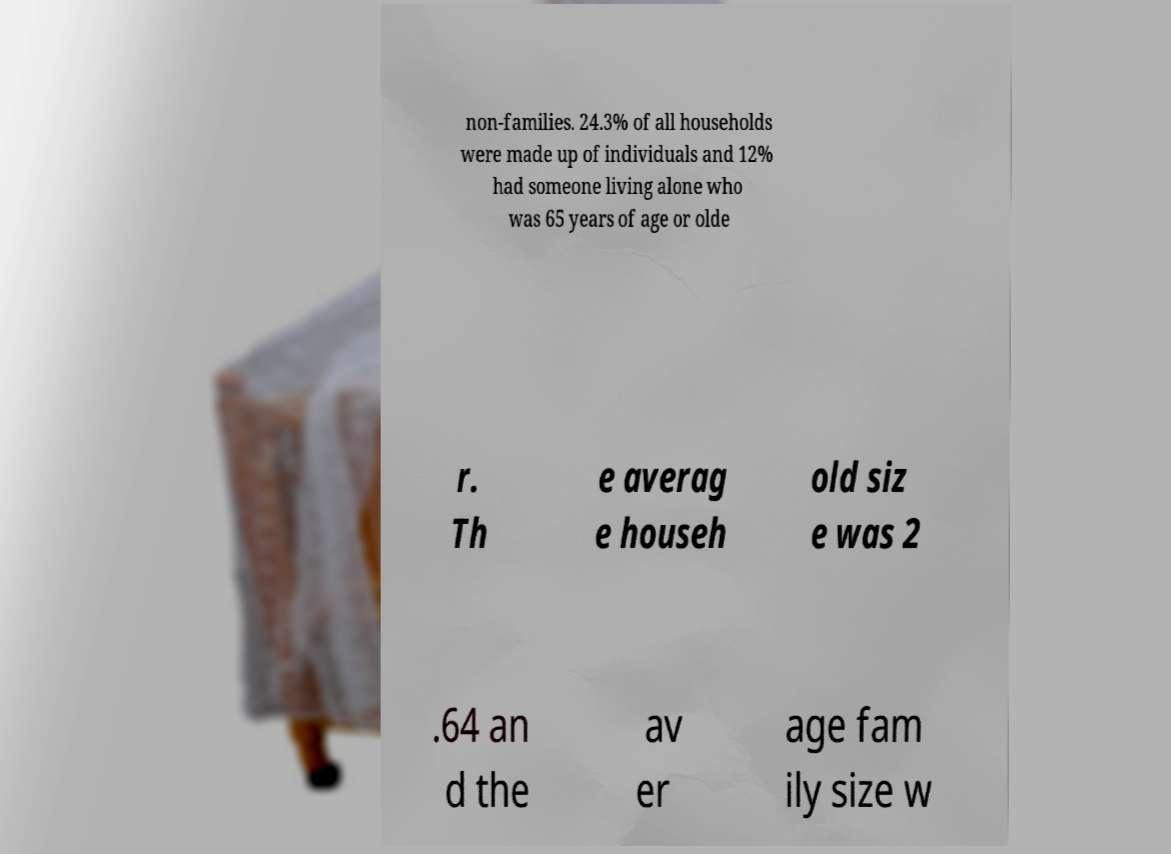There's text embedded in this image that I need extracted. Can you transcribe it verbatim? non-families. 24.3% of all households were made up of individuals and 12% had someone living alone who was 65 years of age or olde r. Th e averag e househ old siz e was 2 .64 an d the av er age fam ily size w 